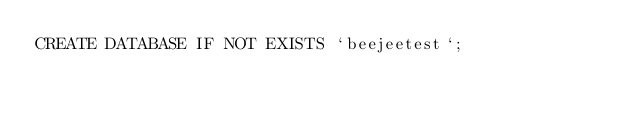<code> <loc_0><loc_0><loc_500><loc_500><_SQL_>CREATE DATABASE IF NOT EXISTS `beejeetest`;
</code> 